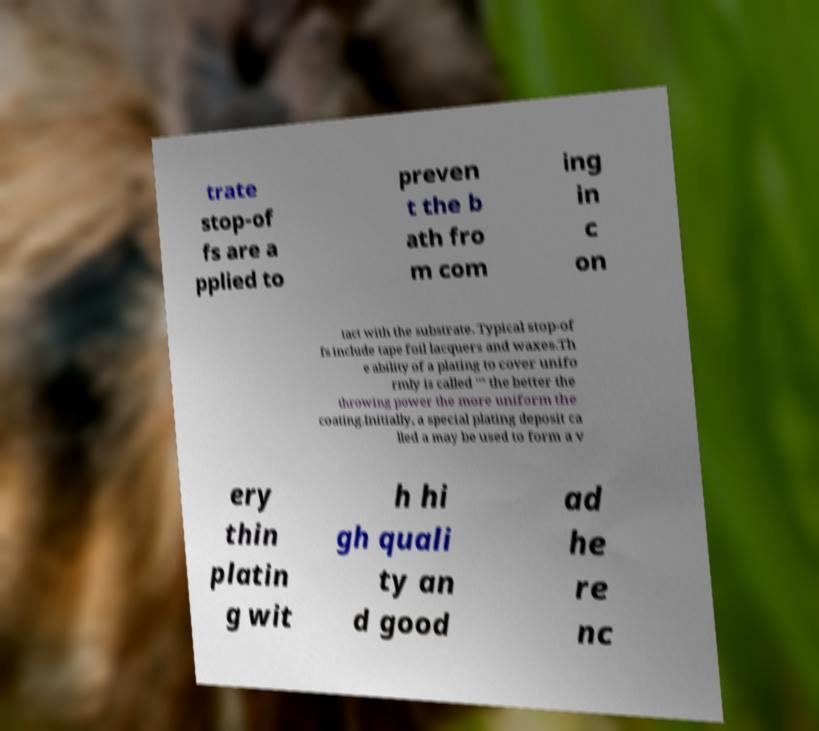Please read and relay the text visible in this image. What does it say? trate stop-of fs are a pplied to preven t the b ath fro m com ing in c on tact with the substrate. Typical stop-of fs include tape foil lacquers and waxes.Th e ability of a plating to cover unifo rmly is called "" the better the throwing power the more uniform the coating.Initially, a special plating deposit ca lled a may be used to form a v ery thin platin g wit h hi gh quali ty an d good ad he re nc 